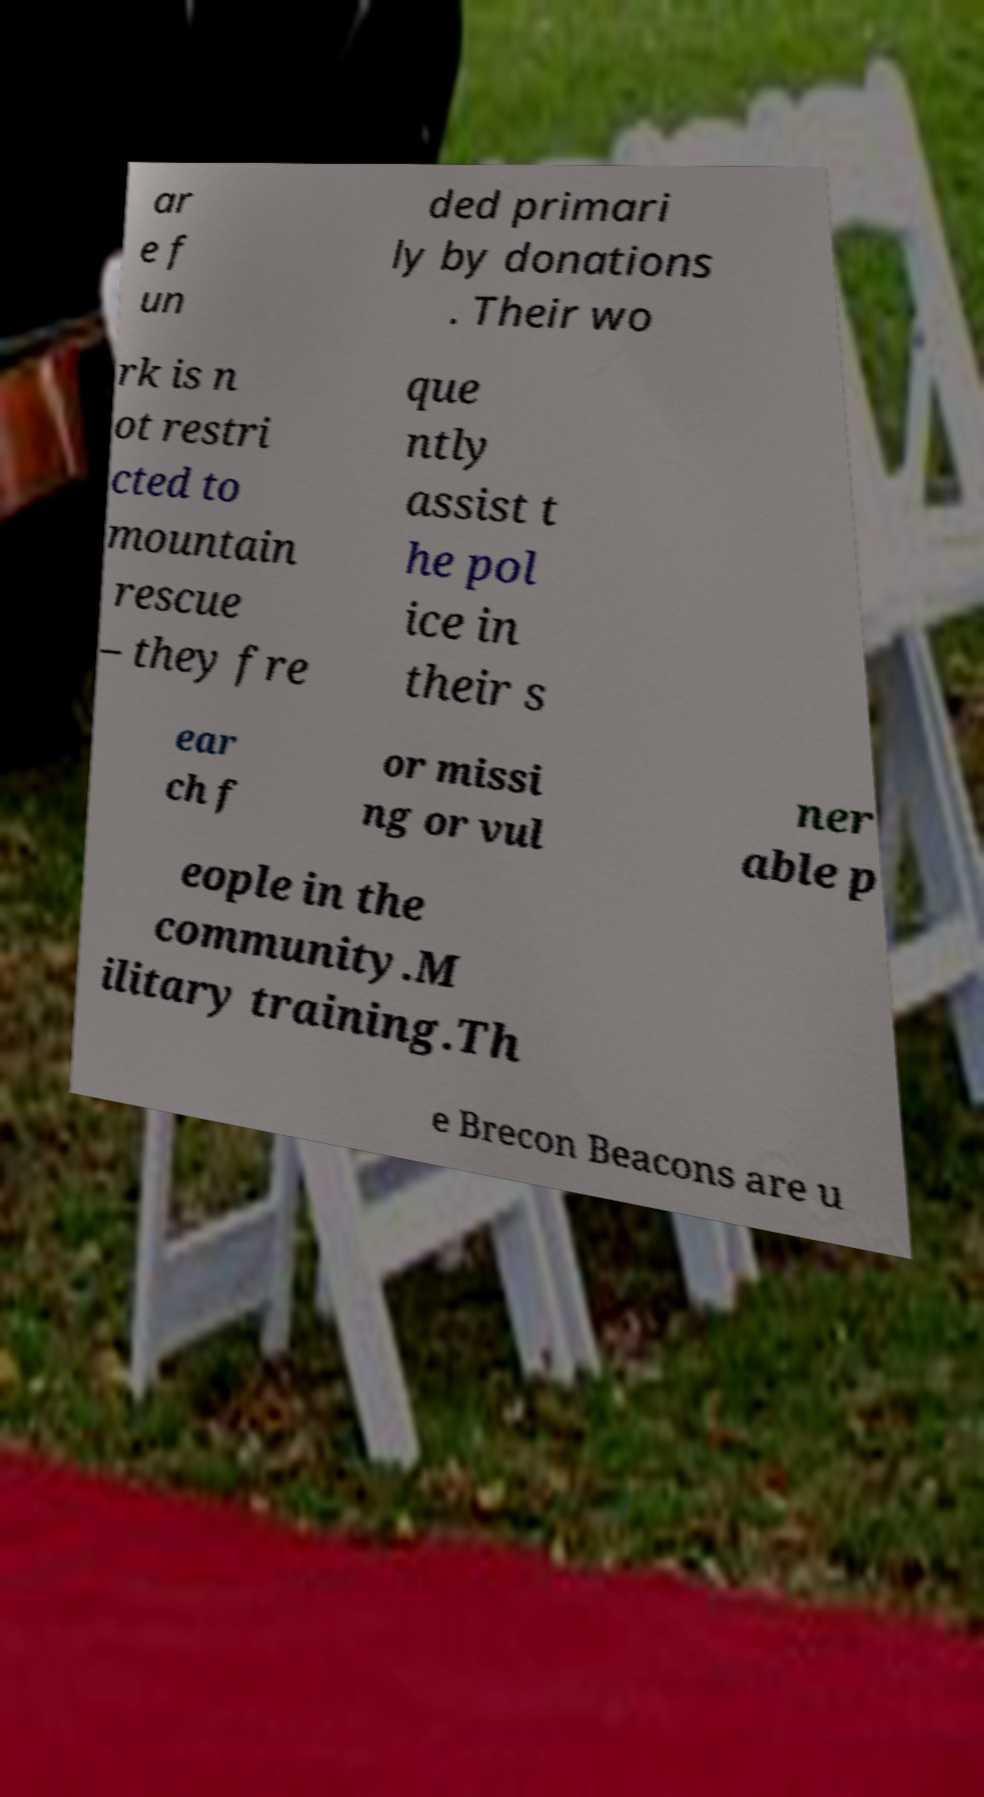What messages or text are displayed in this image? I need them in a readable, typed format. ar e f un ded primari ly by donations . Their wo rk is n ot restri cted to mountain rescue – they fre que ntly assist t he pol ice in their s ear ch f or missi ng or vul ner able p eople in the community.M ilitary training.Th e Brecon Beacons are u 